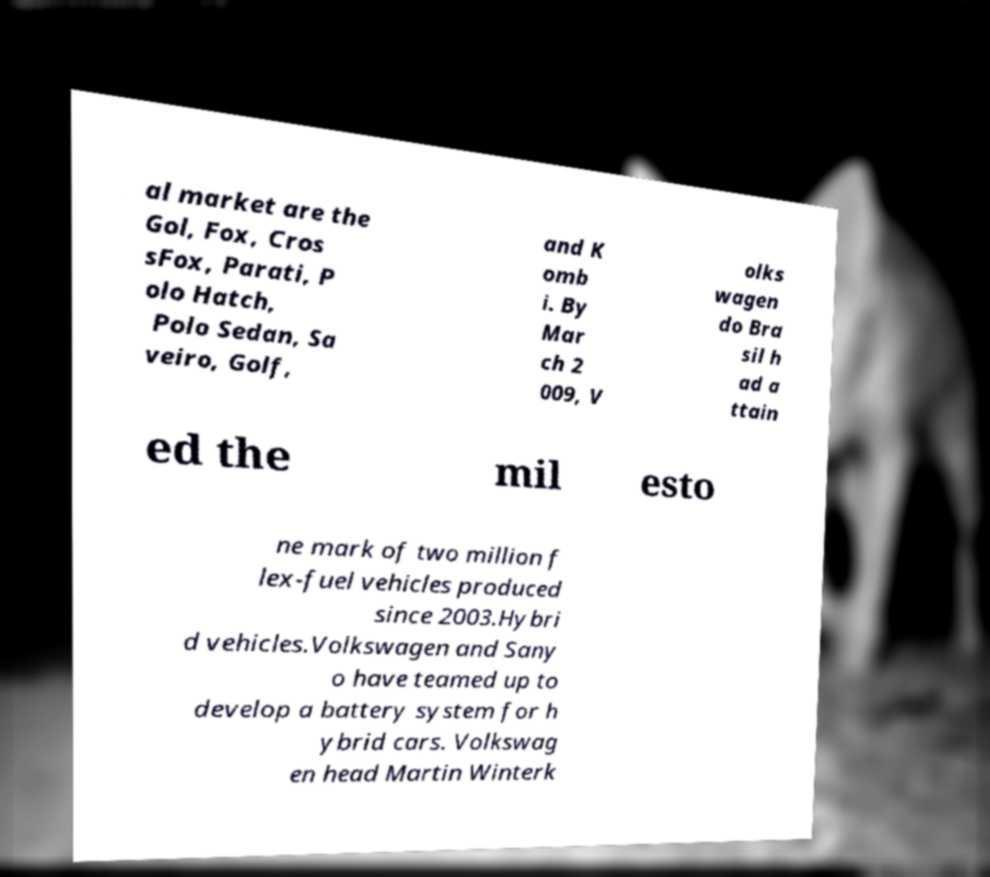Can you accurately transcribe the text from the provided image for me? al market are the Gol, Fox, Cros sFox, Parati, P olo Hatch, Polo Sedan, Sa veiro, Golf, and K omb i. By Mar ch 2 009, V olks wagen do Bra sil h ad a ttain ed the mil esto ne mark of two million f lex-fuel vehicles produced since 2003.Hybri d vehicles.Volkswagen and Sany o have teamed up to develop a battery system for h ybrid cars. Volkswag en head Martin Winterk 